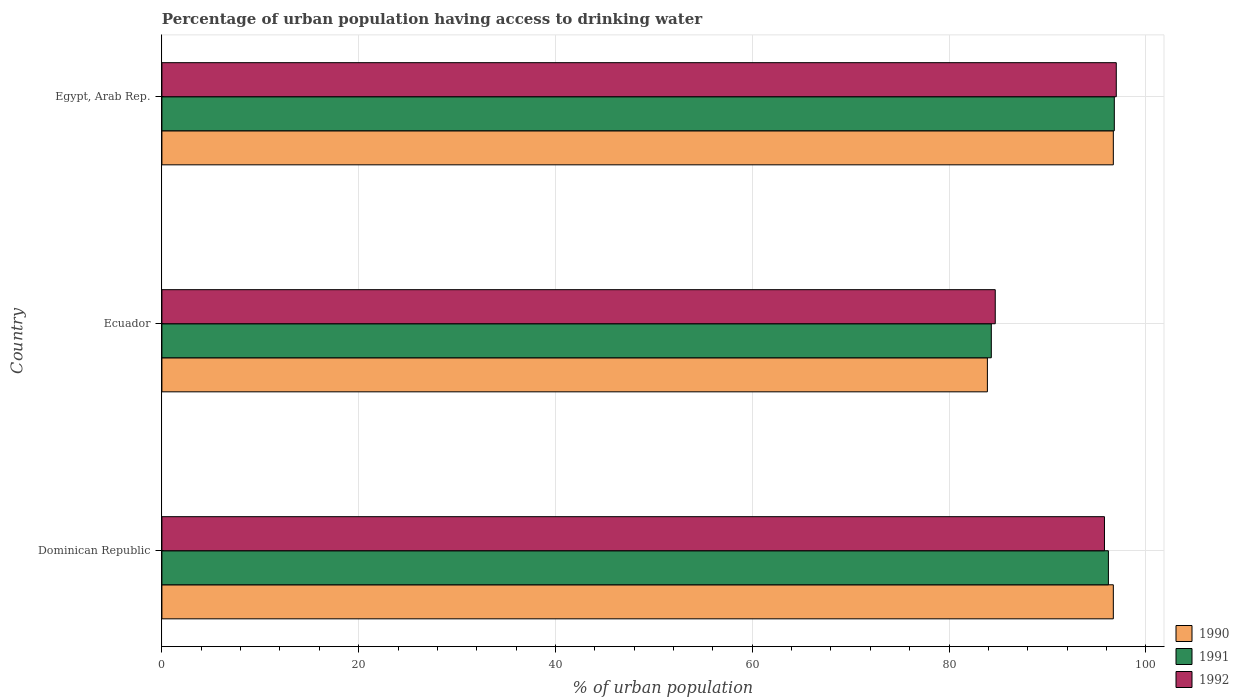How many different coloured bars are there?
Offer a terse response. 3. How many bars are there on the 3rd tick from the top?
Provide a succinct answer. 3. What is the label of the 2nd group of bars from the top?
Provide a succinct answer. Ecuador. What is the percentage of urban population having access to drinking water in 1991 in Ecuador?
Provide a short and direct response. 84.3. Across all countries, what is the maximum percentage of urban population having access to drinking water in 1990?
Make the answer very short. 96.7. Across all countries, what is the minimum percentage of urban population having access to drinking water in 1992?
Provide a succinct answer. 84.7. In which country was the percentage of urban population having access to drinking water in 1992 maximum?
Provide a succinct answer. Egypt, Arab Rep. In which country was the percentage of urban population having access to drinking water in 1992 minimum?
Your response must be concise. Ecuador. What is the total percentage of urban population having access to drinking water in 1992 in the graph?
Provide a short and direct response. 277.5. What is the difference between the percentage of urban population having access to drinking water in 1992 in Dominican Republic and that in Egypt, Arab Rep.?
Provide a short and direct response. -1.2. What is the average percentage of urban population having access to drinking water in 1990 per country?
Give a very brief answer. 92.43. What is the difference between the percentage of urban population having access to drinking water in 1990 and percentage of urban population having access to drinking water in 1992 in Ecuador?
Ensure brevity in your answer.  -0.8. In how many countries, is the percentage of urban population having access to drinking water in 1991 greater than 76 %?
Keep it short and to the point. 3. What is the ratio of the percentage of urban population having access to drinking water in 1992 in Dominican Republic to that in Ecuador?
Provide a short and direct response. 1.13. Is the percentage of urban population having access to drinking water in 1991 in Ecuador less than that in Egypt, Arab Rep.?
Ensure brevity in your answer.  Yes. What is the difference between the highest and the second highest percentage of urban population having access to drinking water in 1992?
Give a very brief answer. 1.2. What is the difference between the highest and the lowest percentage of urban population having access to drinking water in 1990?
Make the answer very short. 12.8. In how many countries, is the percentage of urban population having access to drinking water in 1991 greater than the average percentage of urban population having access to drinking water in 1991 taken over all countries?
Offer a very short reply. 2. Is the sum of the percentage of urban population having access to drinking water in 1990 in Ecuador and Egypt, Arab Rep. greater than the maximum percentage of urban population having access to drinking water in 1991 across all countries?
Your answer should be very brief. Yes. What does the 1st bar from the top in Dominican Republic represents?
Your response must be concise. 1992. How many bars are there?
Offer a terse response. 9. How many countries are there in the graph?
Offer a very short reply. 3. What is the difference between two consecutive major ticks on the X-axis?
Keep it short and to the point. 20. Does the graph contain any zero values?
Your answer should be very brief. No. How are the legend labels stacked?
Your answer should be very brief. Vertical. What is the title of the graph?
Keep it short and to the point. Percentage of urban population having access to drinking water. What is the label or title of the X-axis?
Provide a short and direct response. % of urban population. What is the % of urban population in 1990 in Dominican Republic?
Offer a terse response. 96.7. What is the % of urban population of 1991 in Dominican Republic?
Keep it short and to the point. 96.2. What is the % of urban population of 1992 in Dominican Republic?
Ensure brevity in your answer.  95.8. What is the % of urban population of 1990 in Ecuador?
Your response must be concise. 83.9. What is the % of urban population of 1991 in Ecuador?
Provide a succinct answer. 84.3. What is the % of urban population in 1992 in Ecuador?
Your response must be concise. 84.7. What is the % of urban population of 1990 in Egypt, Arab Rep.?
Give a very brief answer. 96.7. What is the % of urban population in 1991 in Egypt, Arab Rep.?
Give a very brief answer. 96.8. What is the % of urban population of 1992 in Egypt, Arab Rep.?
Provide a succinct answer. 97. Across all countries, what is the maximum % of urban population in 1990?
Offer a terse response. 96.7. Across all countries, what is the maximum % of urban population of 1991?
Ensure brevity in your answer.  96.8. Across all countries, what is the maximum % of urban population of 1992?
Ensure brevity in your answer.  97. Across all countries, what is the minimum % of urban population of 1990?
Offer a terse response. 83.9. Across all countries, what is the minimum % of urban population of 1991?
Offer a terse response. 84.3. Across all countries, what is the minimum % of urban population in 1992?
Provide a succinct answer. 84.7. What is the total % of urban population in 1990 in the graph?
Your response must be concise. 277.3. What is the total % of urban population of 1991 in the graph?
Provide a succinct answer. 277.3. What is the total % of urban population in 1992 in the graph?
Your response must be concise. 277.5. What is the difference between the % of urban population of 1991 in Dominican Republic and that in Ecuador?
Give a very brief answer. 11.9. What is the difference between the % of urban population of 1992 in Dominican Republic and that in Ecuador?
Give a very brief answer. 11.1. What is the difference between the % of urban population of 1990 in Dominican Republic and that in Egypt, Arab Rep.?
Make the answer very short. 0. What is the difference between the % of urban population of 1992 in Dominican Republic and that in Egypt, Arab Rep.?
Ensure brevity in your answer.  -1.2. What is the difference between the % of urban population of 1990 in Ecuador and that in Egypt, Arab Rep.?
Offer a very short reply. -12.8. What is the difference between the % of urban population of 1990 in Dominican Republic and the % of urban population of 1992 in Ecuador?
Provide a succinct answer. 12. What is the difference between the % of urban population of 1991 in Dominican Republic and the % of urban population of 1992 in Ecuador?
Offer a very short reply. 11.5. What is the difference between the % of urban population in 1990 in Dominican Republic and the % of urban population in 1992 in Egypt, Arab Rep.?
Make the answer very short. -0.3. What is the difference between the % of urban population of 1991 in Dominican Republic and the % of urban population of 1992 in Egypt, Arab Rep.?
Provide a succinct answer. -0.8. What is the difference between the % of urban population in 1990 in Ecuador and the % of urban population in 1992 in Egypt, Arab Rep.?
Your answer should be very brief. -13.1. What is the average % of urban population of 1990 per country?
Ensure brevity in your answer.  92.43. What is the average % of urban population of 1991 per country?
Provide a short and direct response. 92.43. What is the average % of urban population in 1992 per country?
Your answer should be compact. 92.5. What is the difference between the % of urban population in 1990 and % of urban population in 1992 in Dominican Republic?
Provide a short and direct response. 0.9. What is the difference between the % of urban population of 1990 and % of urban population of 1992 in Ecuador?
Provide a short and direct response. -0.8. What is the difference between the % of urban population in 1990 and % of urban population in 1991 in Egypt, Arab Rep.?
Offer a terse response. -0.1. What is the difference between the % of urban population of 1991 and % of urban population of 1992 in Egypt, Arab Rep.?
Offer a terse response. -0.2. What is the ratio of the % of urban population in 1990 in Dominican Republic to that in Ecuador?
Provide a short and direct response. 1.15. What is the ratio of the % of urban population in 1991 in Dominican Republic to that in Ecuador?
Provide a short and direct response. 1.14. What is the ratio of the % of urban population of 1992 in Dominican Republic to that in Ecuador?
Your response must be concise. 1.13. What is the ratio of the % of urban population in 1991 in Dominican Republic to that in Egypt, Arab Rep.?
Ensure brevity in your answer.  0.99. What is the ratio of the % of urban population of 1992 in Dominican Republic to that in Egypt, Arab Rep.?
Give a very brief answer. 0.99. What is the ratio of the % of urban population of 1990 in Ecuador to that in Egypt, Arab Rep.?
Offer a terse response. 0.87. What is the ratio of the % of urban population in 1991 in Ecuador to that in Egypt, Arab Rep.?
Make the answer very short. 0.87. What is the ratio of the % of urban population in 1992 in Ecuador to that in Egypt, Arab Rep.?
Give a very brief answer. 0.87. What is the difference between the highest and the second highest % of urban population of 1990?
Keep it short and to the point. 0. What is the difference between the highest and the second highest % of urban population of 1991?
Give a very brief answer. 0.6. What is the difference between the highest and the second highest % of urban population in 1992?
Your response must be concise. 1.2. What is the difference between the highest and the lowest % of urban population in 1992?
Give a very brief answer. 12.3. 